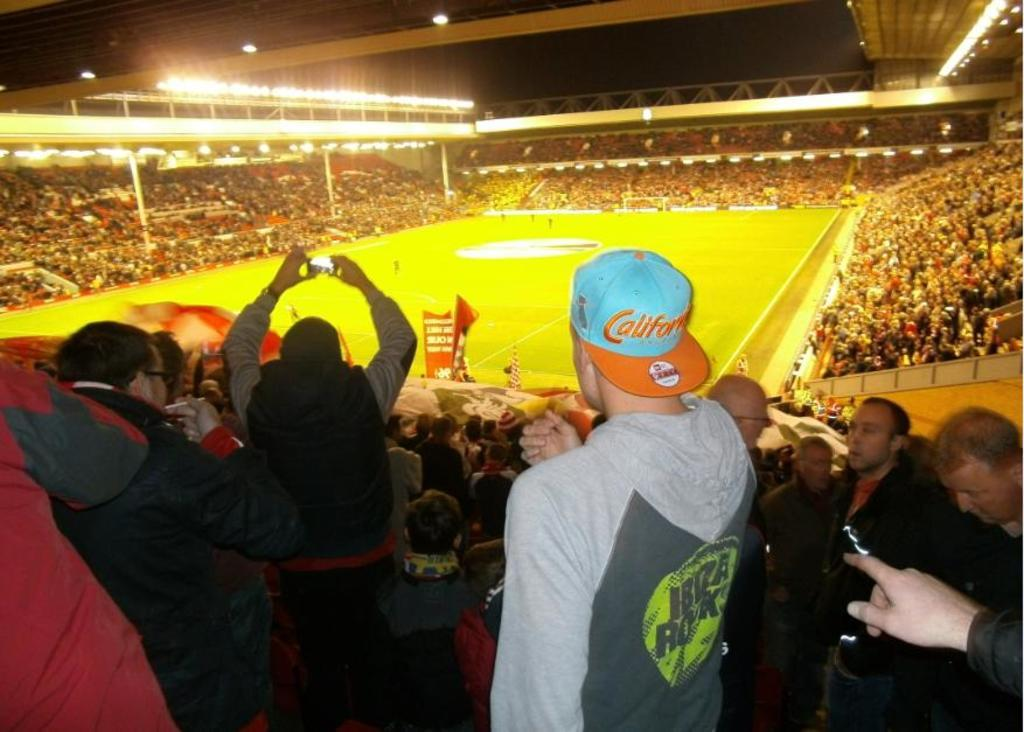What type of location is depicted in the image? The image is of a stadium. What are the people in the stadium doing? There are groups of people standing and sitting in the stadium. What decorative elements can be seen in the stadium? There are flags present in the stadium. What feature allows the stadium to be used at night? There are lights in the stadium. What can be seen in the background of the image? The sky is visible in the background of the image. What type of magic is being performed in the stadium? There is no magic being performed in the image; it depicts a stadium with people, flags, lights, and a visible sky. How does the air quality in the stadium affect the people's experience? The image does not provide information about the air quality in the stadium, so it cannot be determined from the picture. 